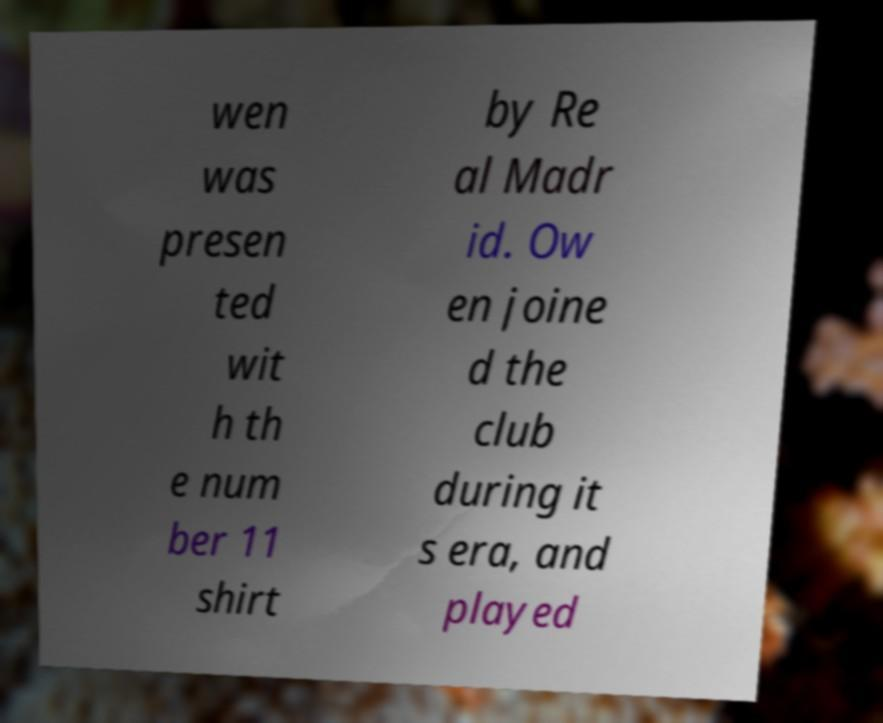Please identify and transcribe the text found in this image. wen was presen ted wit h th e num ber 11 shirt by Re al Madr id. Ow en joine d the club during it s era, and played 